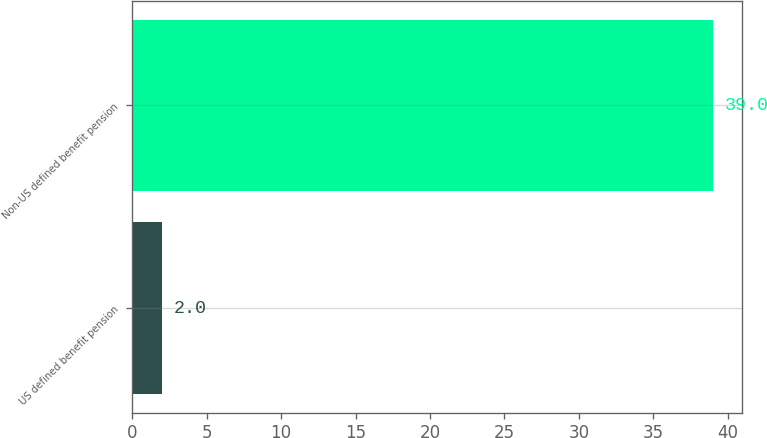Convert chart to OTSL. <chart><loc_0><loc_0><loc_500><loc_500><bar_chart><fcel>US defined benefit pension<fcel>Non-US defined benefit pension<nl><fcel>2<fcel>39<nl></chart> 